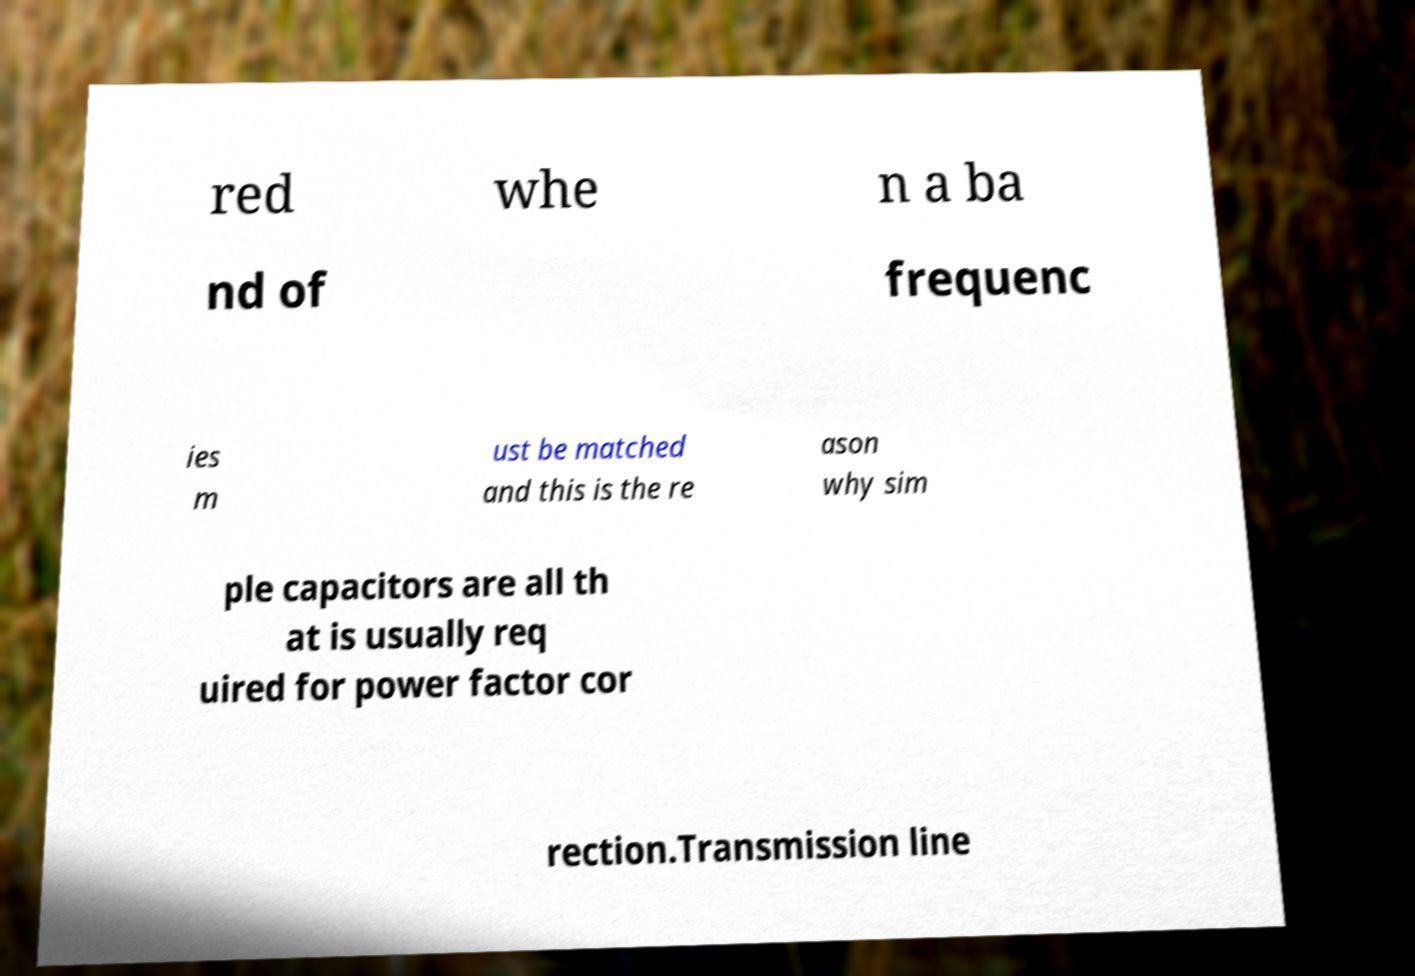Could you assist in decoding the text presented in this image and type it out clearly? red whe n a ba nd of frequenc ies m ust be matched and this is the re ason why sim ple capacitors are all th at is usually req uired for power factor cor rection.Transmission line 